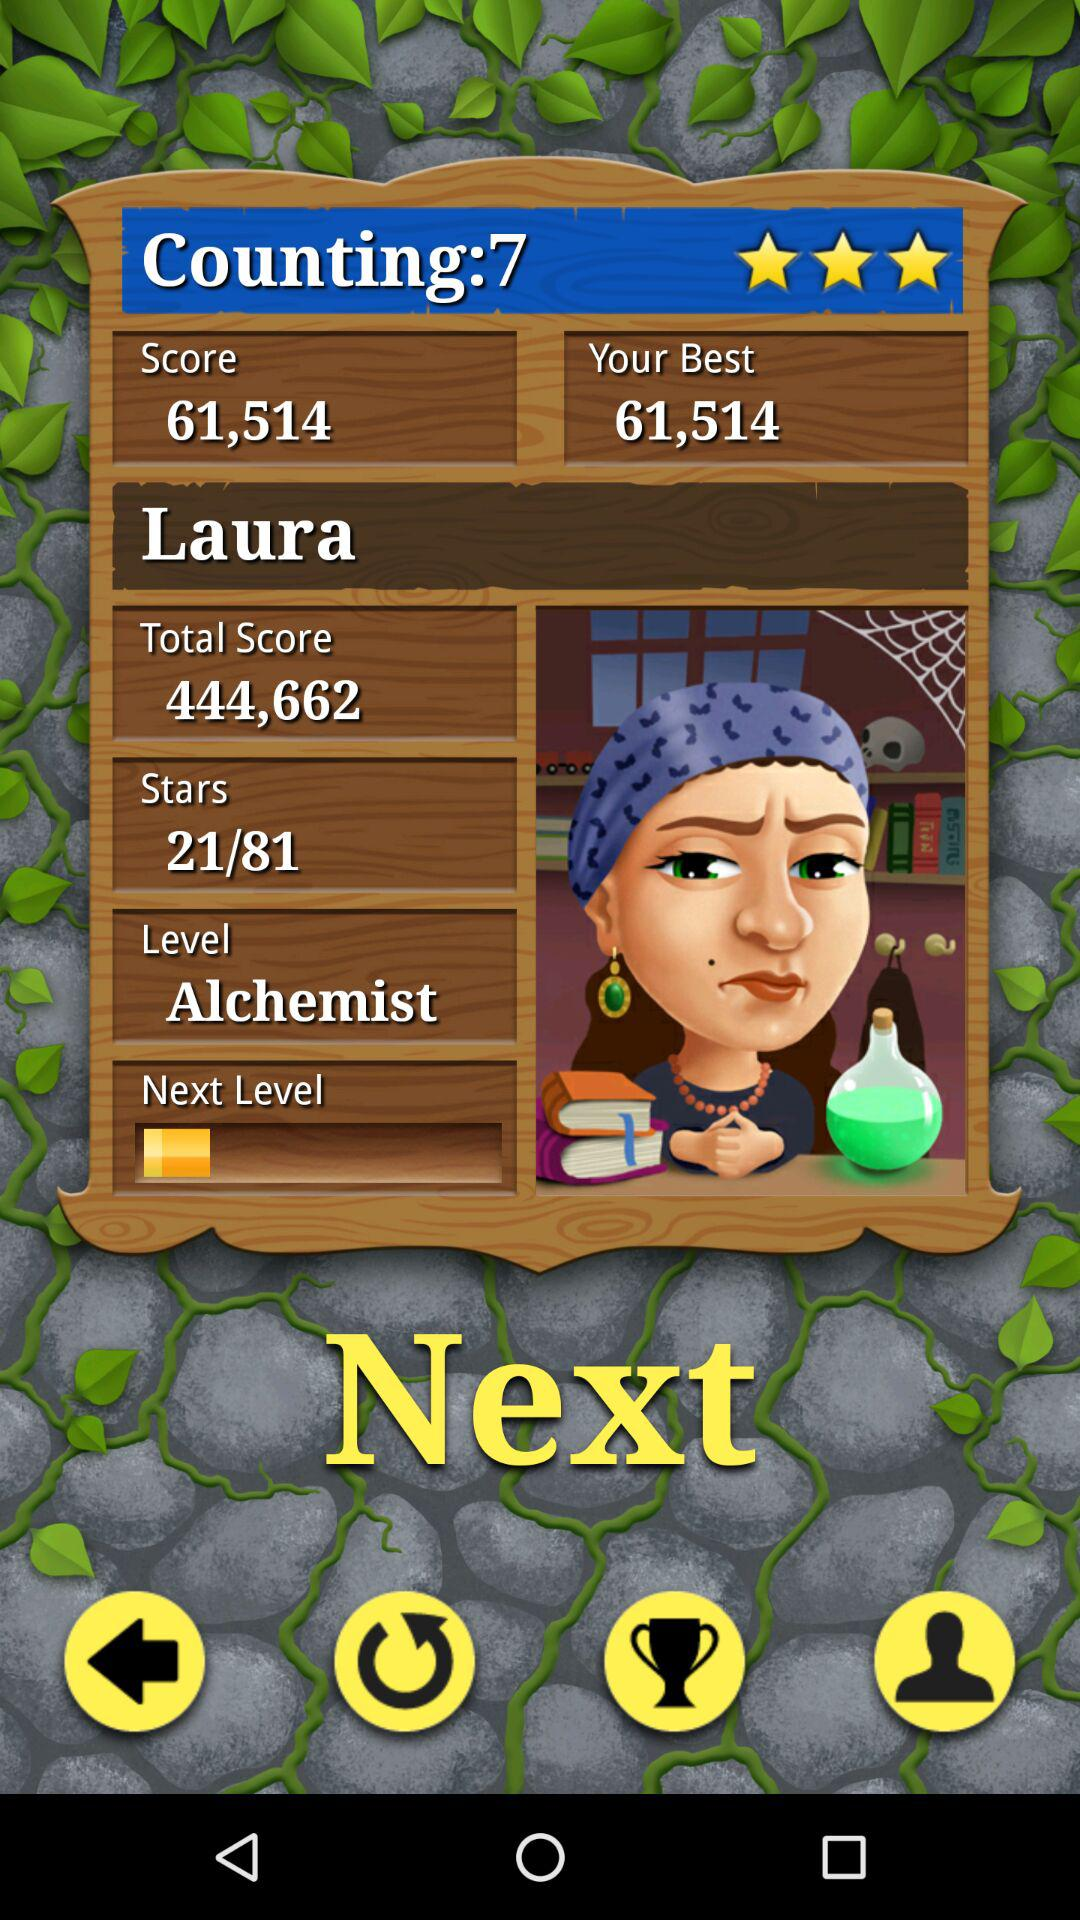What is the "Counting"? The "Counting" is 7. 